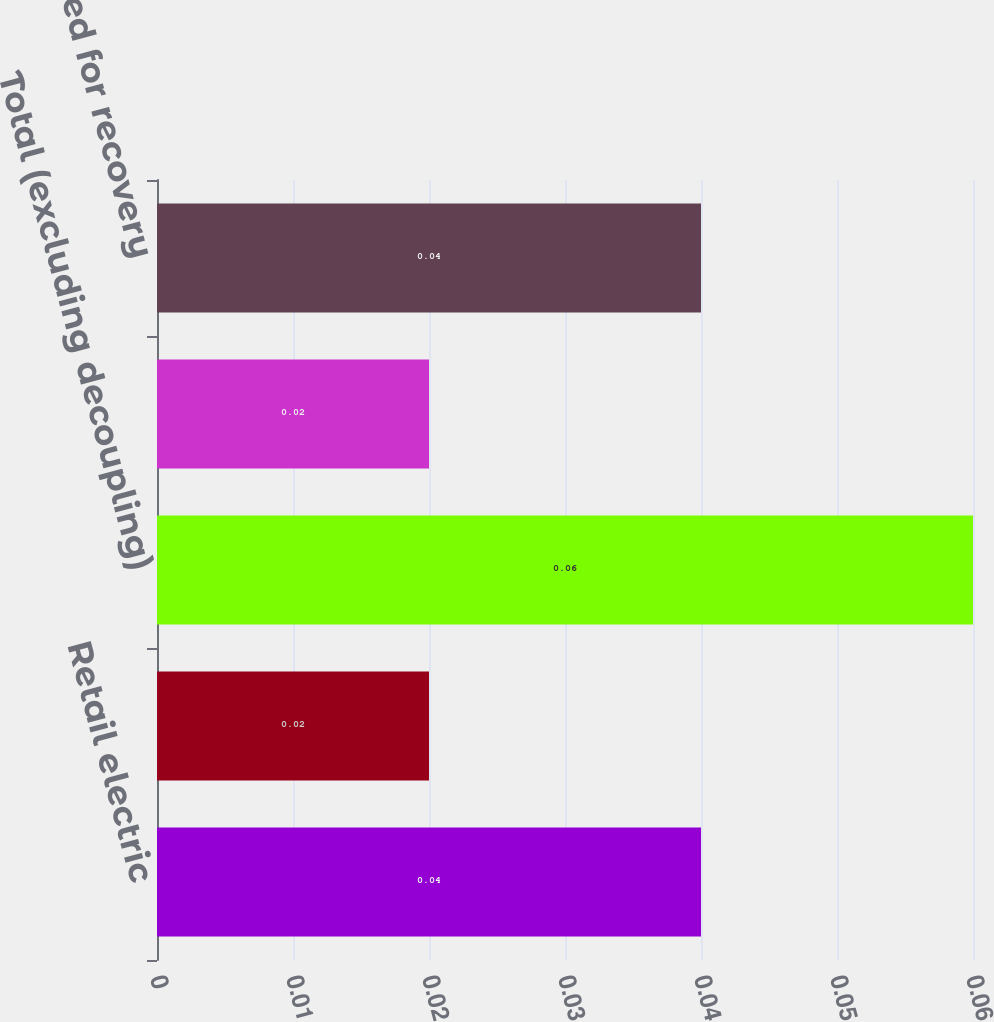Convert chart to OTSL. <chart><loc_0><loc_0><loc_500><loc_500><bar_chart><fcel>Retail electric<fcel>Firm natural gas<fcel>Total (excluding decoupling)<fcel>Decoupling - Minnesota<fcel>Total (adjusted for recovery<nl><fcel>0.04<fcel>0.02<fcel>0.06<fcel>0.02<fcel>0.04<nl></chart> 